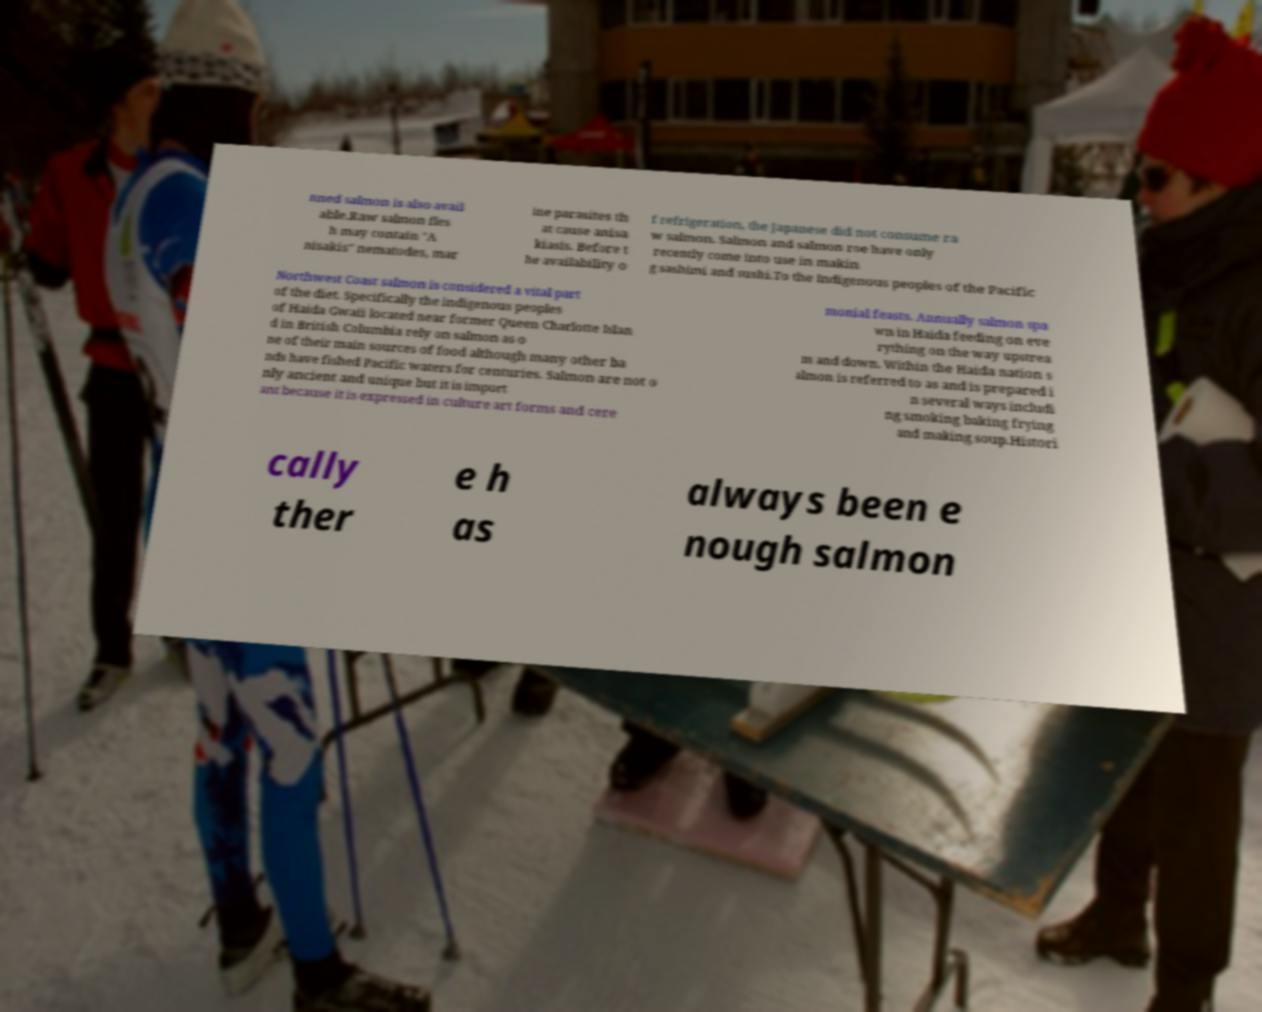For documentation purposes, I need the text within this image transcribed. Could you provide that? nned salmon is also avail able.Raw salmon fles h may contain "A nisakis" nematodes, mar ine parasites th at cause anisa kiasis. Before t he availability o f refrigeration, the Japanese did not consume ra w salmon. Salmon and salmon roe have only recently come into use in makin g sashimi and sushi.To the Indigenous peoples of the Pacific Northwest Coast salmon is considered a vital part of the diet. Specifically the indigenous peoples of Haida Gwaii located near former Queen Charlotte Islan d in British Columbia rely on salmon as o ne of their main sources of food although many other ba nds have fished Pacific waters for centuries. Salmon are not o nly ancient and unique but it is import ant because it is expressed in culture art forms and cere monial feasts. Annually salmon spa wn in Haida feeding on eve rything on the way upstrea m and down. Within the Haida nation s almon is referred to as and is prepared i n several ways includi ng smoking baking frying and making soup.Histori cally ther e h as always been e nough salmon 